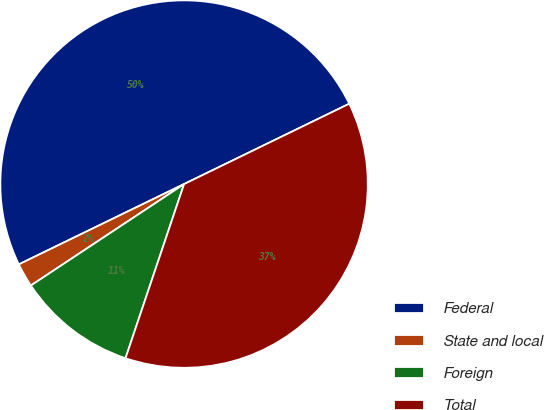<chart> <loc_0><loc_0><loc_500><loc_500><pie_chart><fcel>Federal<fcel>State and local<fcel>Foreign<fcel>Total<nl><fcel>50.0%<fcel>2.11%<fcel>10.53%<fcel>37.37%<nl></chart> 